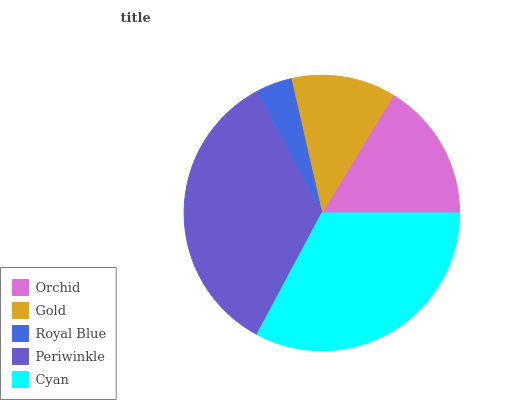Is Royal Blue the minimum?
Answer yes or no. Yes. Is Periwinkle the maximum?
Answer yes or no. Yes. Is Gold the minimum?
Answer yes or no. No. Is Gold the maximum?
Answer yes or no. No. Is Orchid greater than Gold?
Answer yes or no. Yes. Is Gold less than Orchid?
Answer yes or no. Yes. Is Gold greater than Orchid?
Answer yes or no. No. Is Orchid less than Gold?
Answer yes or no. No. Is Orchid the high median?
Answer yes or no. Yes. Is Orchid the low median?
Answer yes or no. Yes. Is Royal Blue the high median?
Answer yes or no. No. Is Cyan the low median?
Answer yes or no. No. 